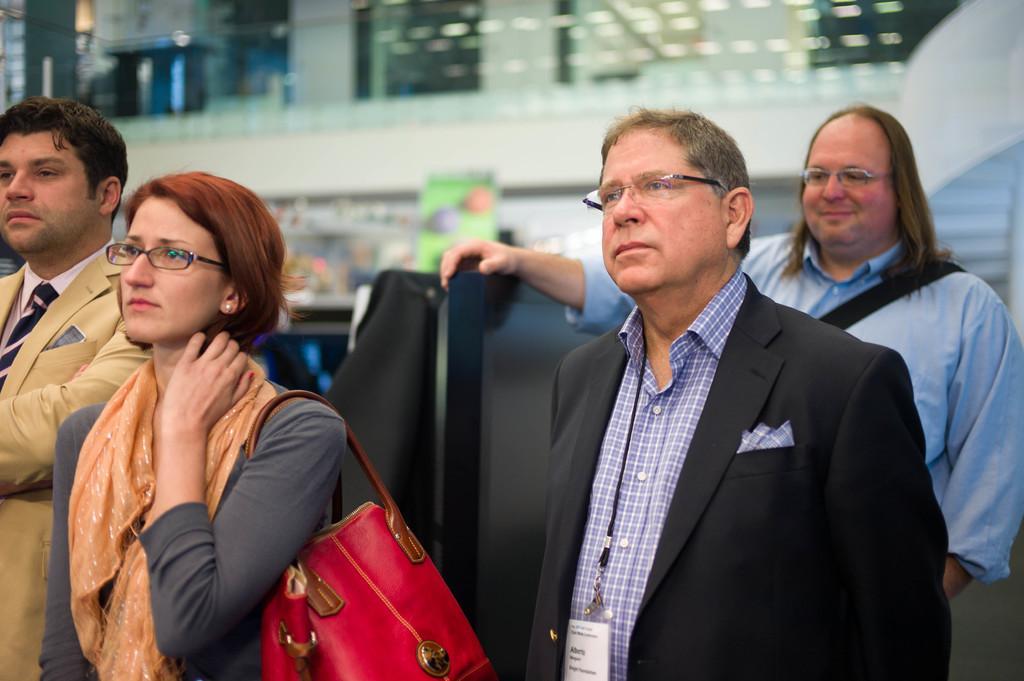In one or two sentences, can you explain what this image depicts? In this picture we see four men and women standing. The woman in grey dress is carrying handbag which is red in color. She is wearing an orange scarf and she's even wearing spectacles. Beside her, we see man in black blazer is wearing ID card. Behind him, we see a man in blue shirt is wearing a black bag and behind him, we see the building and also the windows. 